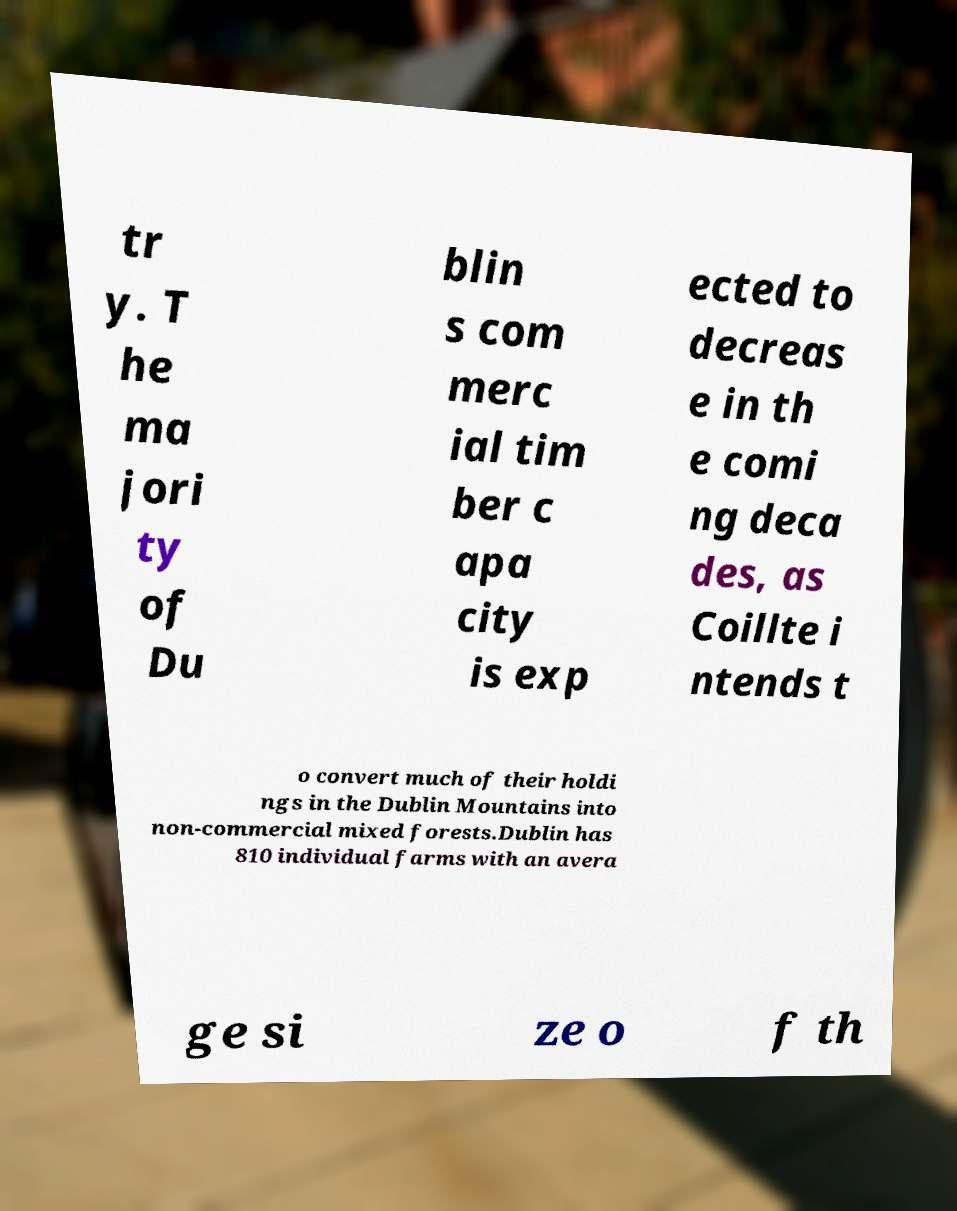I need the written content from this picture converted into text. Can you do that? tr y. T he ma jori ty of Du blin s com merc ial tim ber c apa city is exp ected to decreas e in th e comi ng deca des, as Coillte i ntends t o convert much of their holdi ngs in the Dublin Mountains into non-commercial mixed forests.Dublin has 810 individual farms with an avera ge si ze o f th 